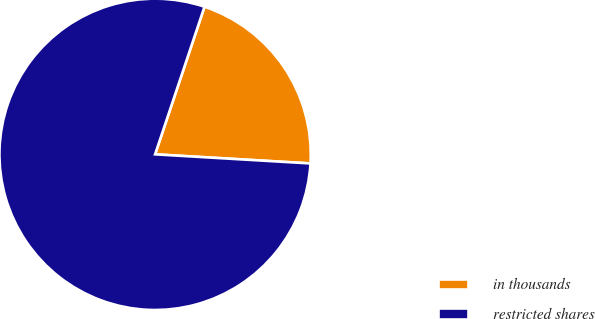Convert chart to OTSL. <chart><loc_0><loc_0><loc_500><loc_500><pie_chart><fcel>in thousands<fcel>restricted shares<nl><fcel>20.79%<fcel>79.21%<nl></chart> 